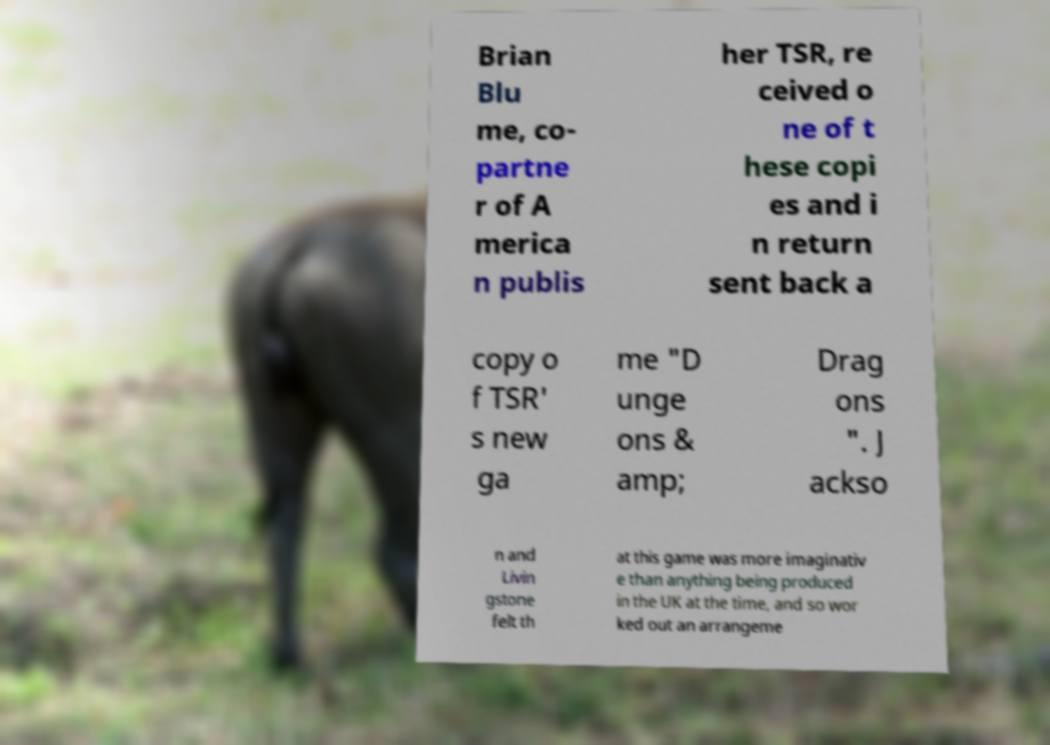I need the written content from this picture converted into text. Can you do that? Brian Blu me, co- partne r of A merica n publis her TSR, re ceived o ne of t hese copi es and i n return sent back a copy o f TSR' s new ga me "D unge ons & amp; Drag ons ". J ackso n and Livin gstone felt th at this game was more imaginativ e than anything being produced in the UK at the time, and so wor ked out an arrangeme 